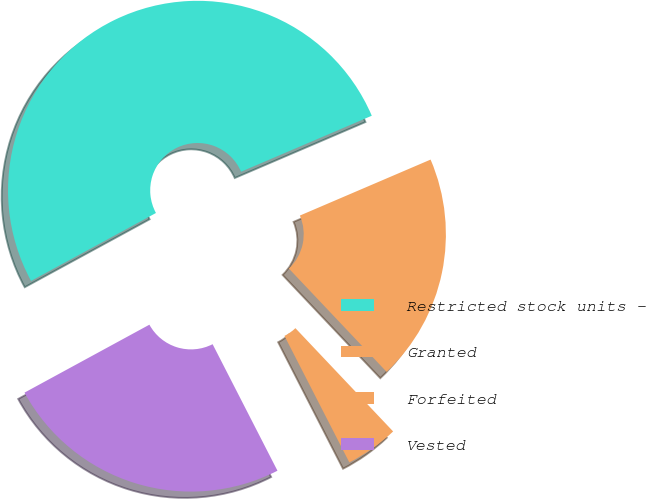Convert chart to OTSL. <chart><loc_0><loc_0><loc_500><loc_500><pie_chart><fcel>Restricted stock units -<fcel>Granted<fcel>Forfeited<fcel>Vested<nl><fcel>51.49%<fcel>19.38%<fcel>4.52%<fcel>24.61%<nl></chart> 